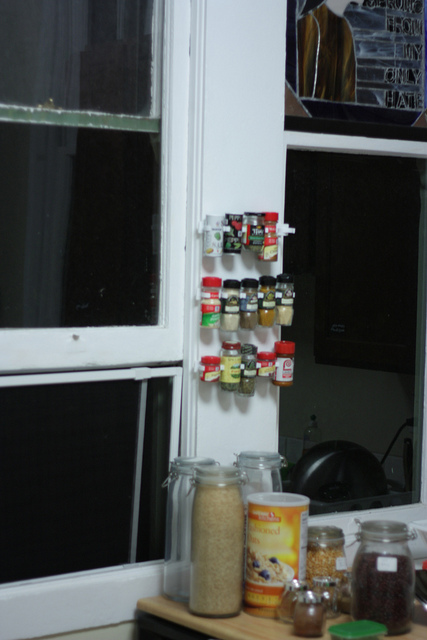<image>What type of nuts are in the jar? I don't know what type of nuts are in the jar. It can be peanuts, seeds, or cashews. What type of nuts are in the jar? I am not sure what type of nuts are in the jar. It can be peanuts, seeds, cashews or pine nuts. 